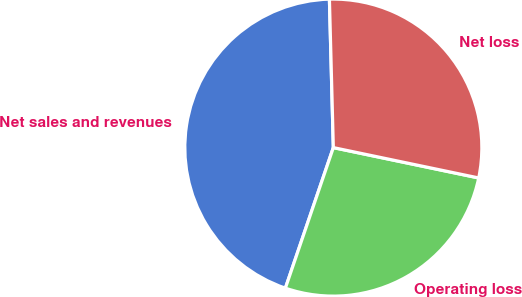Convert chart. <chart><loc_0><loc_0><loc_500><loc_500><pie_chart><fcel>Net sales and revenues<fcel>Operating loss<fcel>Net loss<nl><fcel>44.35%<fcel>26.96%<fcel>28.7%<nl></chart> 